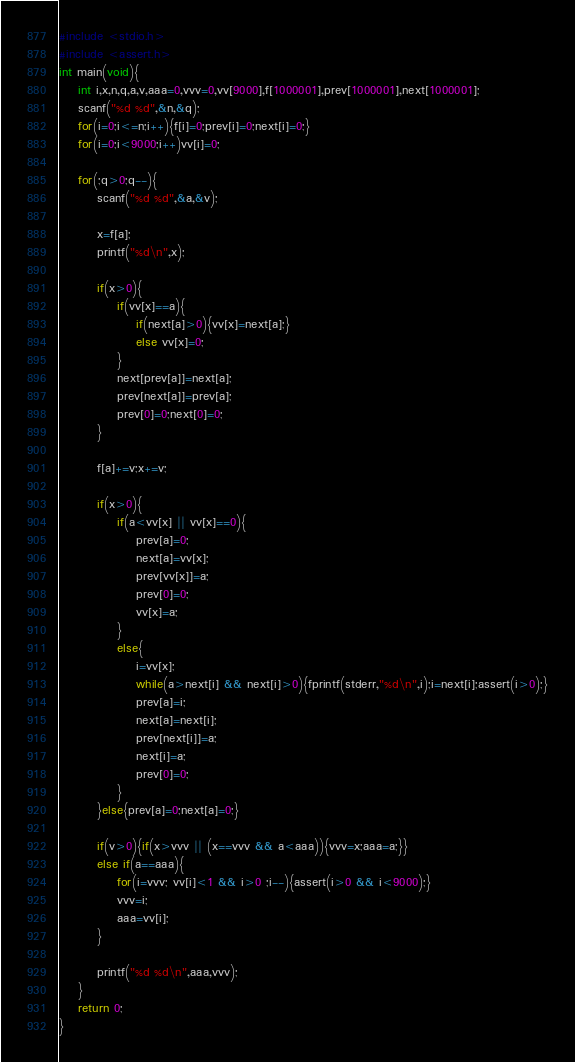<code> <loc_0><loc_0><loc_500><loc_500><_C_>#include <stdio.h>
#include <assert.h>
int main(void){
	int i,x,n,q,a,v,aaa=0,vvv=0,vv[9000],f[1000001],prev[1000001],next[1000001];
	scanf("%d %d",&n,&q);
	for(i=0;i<=n;i++){f[i]=0;prev[i]=0;next[i]=0;}
	for(i=0;i<9000;i++)vv[i]=0;

	for(;q>0;q--){
		scanf("%d %d",&a,&v);

		x=f[a];
		printf("%d\n",x);

		if(x>0){
			if(vv[x]==a){
				if(next[a]>0){vv[x]=next[a];}
				else vv[x]=0;
			}
			next[prev[a]]=next[a];
			prev[next[a]]=prev[a];
			prev[0]=0;next[0]=0;
		}

		f[a]+=v;x+=v;
		
		if(x>0){
			if(a<vv[x] || vv[x]==0){
				prev[a]=0;
				next[a]=vv[x];
				prev[vv[x]]=a;
				prev[0]=0;
				vv[x]=a;
			}
			else{
				i=vv[x];
				while(a>next[i] && next[i]>0){fprintf(stderr,"%d\n",i);i=next[i];assert(i>0);}
				prev[a]=i;
				next[a]=next[i];
				prev[next[i]]=a;
				next[i]=a;
				prev[0]=0;
			}
		}else{prev[a]=0;next[a]=0;}

		if(v>0){if(x>vvv || (x==vvv && a<aaa)){vvv=x;aaa=a;}}
		else if(a==aaa){
			for(i=vvv; vv[i]<1 && i>0 ;i--){assert(i>0 && i<9000);}
			vvv=i;
			aaa=vv[i];
		}

		printf("%d %d\n",aaa,vvv);
	}
	return 0;
}</code> 